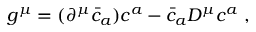<formula> <loc_0><loc_0><loc_500><loc_500>g ^ { \mu } = ( \partial ^ { \mu } \bar { c } _ { a } ) c ^ { a } - \bar { c } _ { a } D ^ { \mu } c ^ { a } ,</formula> 